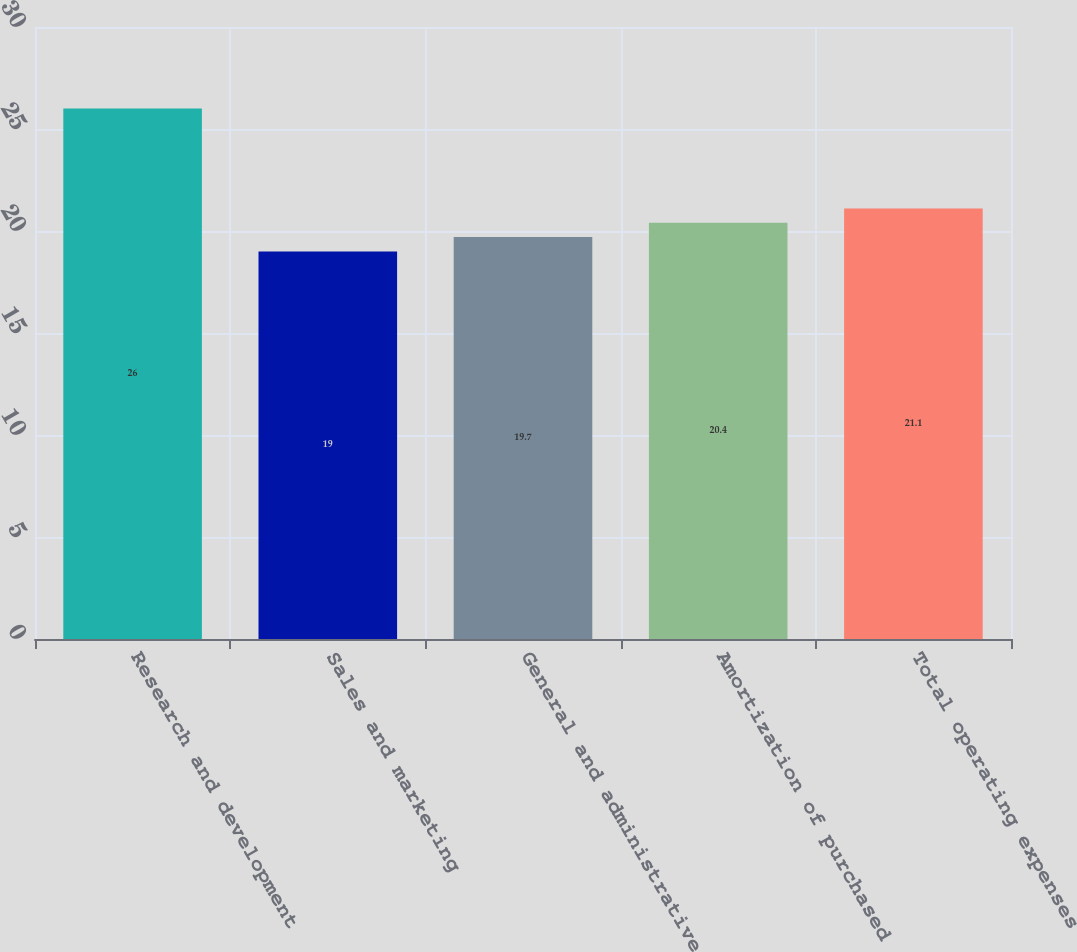<chart> <loc_0><loc_0><loc_500><loc_500><bar_chart><fcel>Research and development<fcel>Sales and marketing<fcel>General and administrative<fcel>Amortization of purchased<fcel>Total operating expenses<nl><fcel>26<fcel>19<fcel>19.7<fcel>20.4<fcel>21.1<nl></chart> 